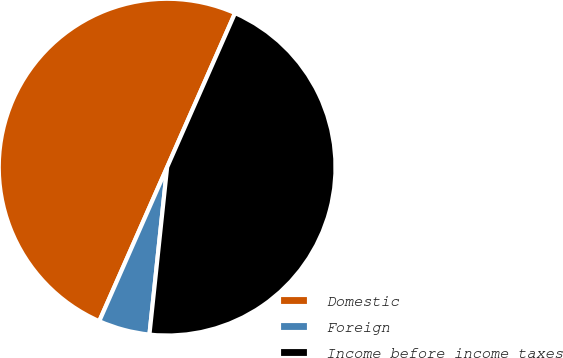<chart> <loc_0><loc_0><loc_500><loc_500><pie_chart><fcel>Domestic<fcel>Foreign<fcel>Income before income taxes<nl><fcel>50.0%<fcel>4.93%<fcel>45.07%<nl></chart> 